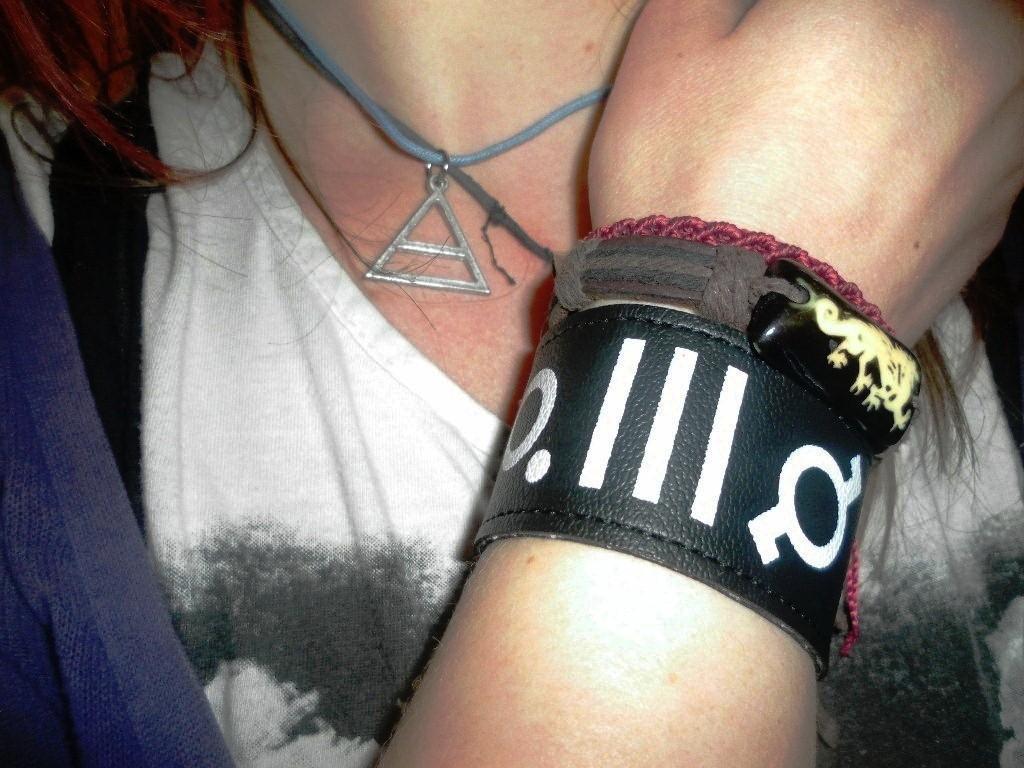In one or two sentences, can you explain what this image depicts? In this picture we can see a woman, she wore a hand band. 